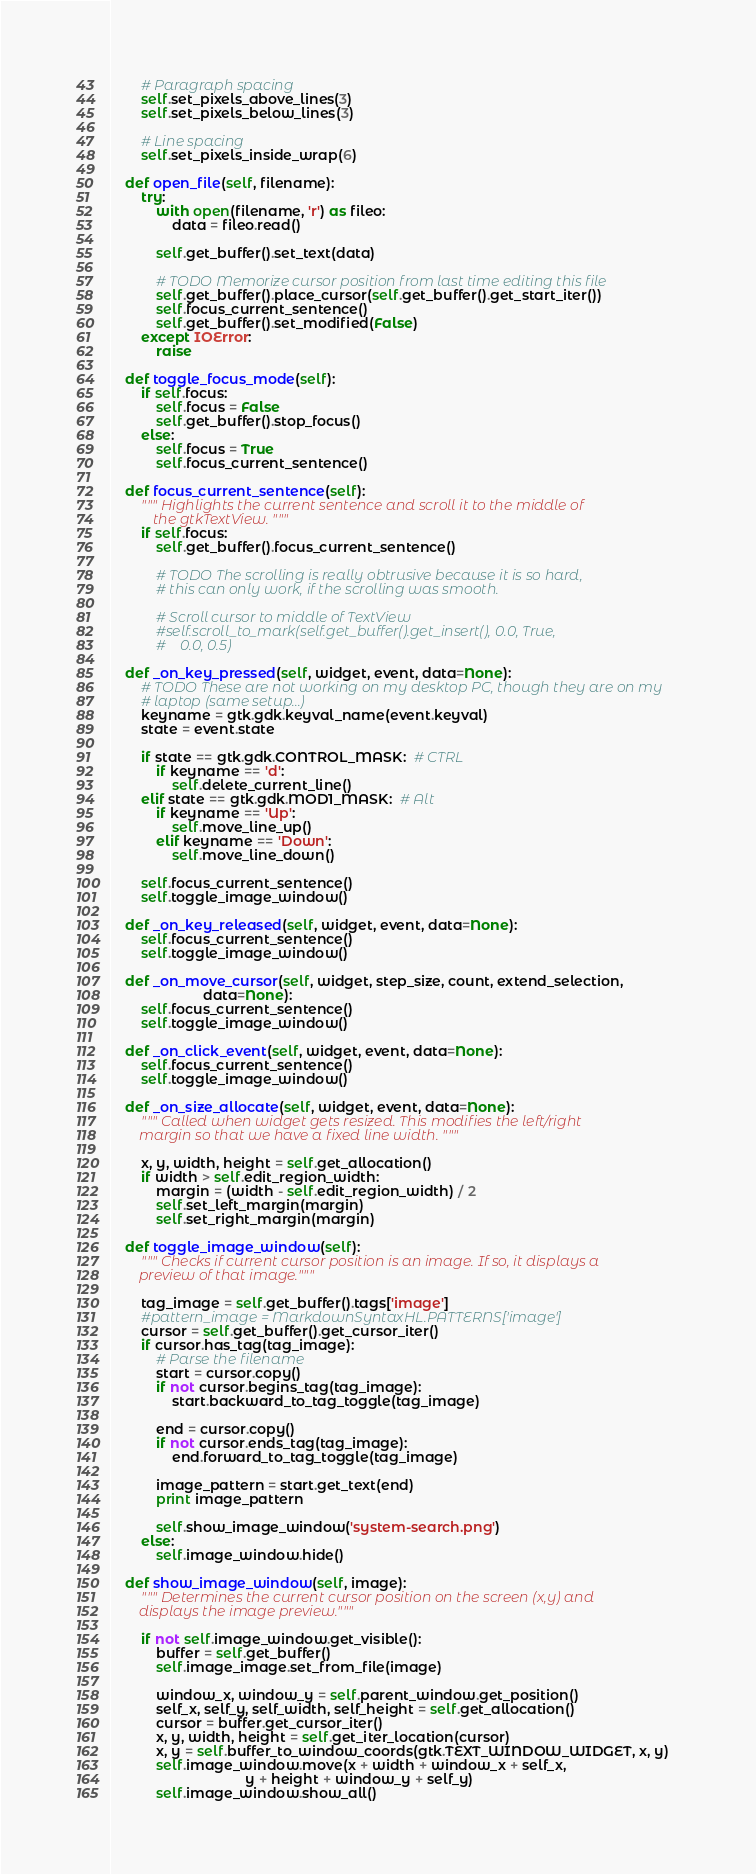Convert code to text. <code><loc_0><loc_0><loc_500><loc_500><_Python_>
        # Paragraph spacing
        self.set_pixels_above_lines(3)
        self.set_pixels_below_lines(3)

        # Line spacing
        self.set_pixels_inside_wrap(6)

    def open_file(self, filename):
        try:
            with open(filename, 'r') as fileo:
                data = fileo.read()

            self.get_buffer().set_text(data)

            # TODO Memorize cursor position from last time editing this file
            self.get_buffer().place_cursor(self.get_buffer().get_start_iter())
            self.focus_current_sentence()
            self.get_buffer().set_modified(False)
        except IOError:
            raise

    def toggle_focus_mode(self):
        if self.focus:
            self.focus = False
            self.get_buffer().stop_focus()
        else:
            self.focus = True
            self.focus_current_sentence()

    def focus_current_sentence(self):
        """ Highlights the current sentence and scroll it to the middle of
            the gtkTextView. """
        if self.focus:
            self.get_buffer().focus_current_sentence()

            # TODO The scrolling is really obtrusive because it is so hard,
            # this can only work, if the scrolling was smooth.

            # Scroll cursor to middle of TextView
            #self.scroll_to_mark(self.get_buffer().get_insert(), 0.0, True,
            #    0.0, 0.5)

    def _on_key_pressed(self, widget, event, data=None):
        # TODO These are not working on my desktop PC, though they are on my
        # laptop (same setup...)
        keyname = gtk.gdk.keyval_name(event.keyval)
        state = event.state

        if state == gtk.gdk.CONTROL_MASK:  # CTRL
            if keyname == 'd':
                self.delete_current_line()
        elif state == gtk.gdk.MOD1_MASK:  # Alt
            if keyname == 'Up':
                self.move_line_up()
            elif keyname == 'Down':
                self.move_line_down()

        self.focus_current_sentence()
        self.toggle_image_window()

    def _on_key_released(self, widget, event, data=None):
        self.focus_current_sentence()
        self.toggle_image_window()

    def _on_move_cursor(self, widget, step_size, count, extend_selection,
                        data=None):
        self.focus_current_sentence()
        self.toggle_image_window()

    def _on_click_event(self, widget, event, data=None):
        self.focus_current_sentence()
        self.toggle_image_window()

    def _on_size_allocate(self, widget, event, data=None):
        """ Called when widget gets resized. This modifies the left/right
        margin so that we have a fixed line width. """

        x, y, width, height = self.get_allocation()
        if width > self.edit_region_width:
            margin = (width - self.edit_region_width) / 2
            self.set_left_margin(margin)
            self.set_right_margin(margin)

    def toggle_image_window(self):
        """ Checks if current cursor position is an image. If so, it displays a
        preview of that image."""

        tag_image = self.get_buffer().tags['image']
        #pattern_image = MarkdownSyntaxHL.PATTERNS['image']
        cursor = self.get_buffer().get_cursor_iter()
        if cursor.has_tag(tag_image):
            # Parse the filename
            start = cursor.copy()
            if not cursor.begins_tag(tag_image):
                start.backward_to_tag_toggle(tag_image)

            end = cursor.copy()
            if not cursor.ends_tag(tag_image):
                end.forward_to_tag_toggle(tag_image)

            image_pattern = start.get_text(end)
            print image_pattern

            self.show_image_window('system-search.png')
        else:
            self.image_window.hide()

    def show_image_window(self, image):
        """ Determines the current cursor position on the screen (x,y) and
        displays the image preview."""

        if not self.image_window.get_visible():
            buffer = self.get_buffer()
            self.image_image.set_from_file(image)

            window_x, window_y = self.parent_window.get_position()
            self_x, self_y, self_width, self_height = self.get_allocation()
            cursor = buffer.get_cursor_iter()
            x, y, width, height = self.get_iter_location(cursor)
            x, y = self.buffer_to_window_coords(gtk.TEXT_WINDOW_WIDGET, x, y)
            self.image_window.move(x + width + window_x + self_x,
                                   y + height + window_y + self_y)
            self.image_window.show_all()
</code> 